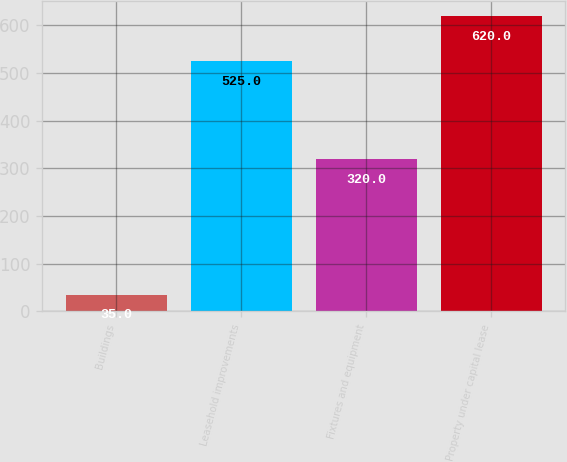Convert chart to OTSL. <chart><loc_0><loc_0><loc_500><loc_500><bar_chart><fcel>Buildings<fcel>Leasehold improvements<fcel>Fixtures and equipment<fcel>Property under capital lease<nl><fcel>35<fcel>525<fcel>320<fcel>620<nl></chart> 